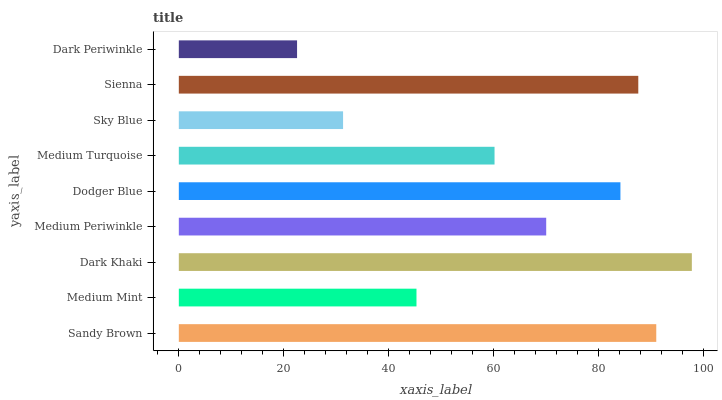Is Dark Periwinkle the minimum?
Answer yes or no. Yes. Is Dark Khaki the maximum?
Answer yes or no. Yes. Is Medium Mint the minimum?
Answer yes or no. No. Is Medium Mint the maximum?
Answer yes or no. No. Is Sandy Brown greater than Medium Mint?
Answer yes or no. Yes. Is Medium Mint less than Sandy Brown?
Answer yes or no. Yes. Is Medium Mint greater than Sandy Brown?
Answer yes or no. No. Is Sandy Brown less than Medium Mint?
Answer yes or no. No. Is Medium Periwinkle the high median?
Answer yes or no. Yes. Is Medium Periwinkle the low median?
Answer yes or no. Yes. Is Dark Periwinkle the high median?
Answer yes or no. No. Is Dodger Blue the low median?
Answer yes or no. No. 